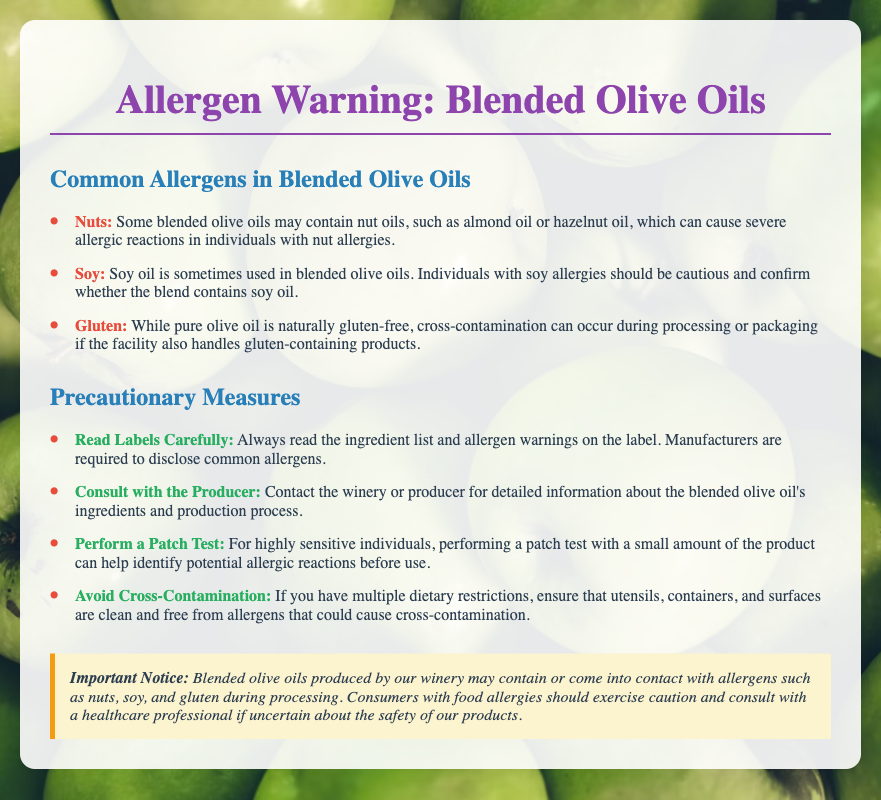What are common allergens in blended olive oils? The common allergens listed in the document include nuts, soy, and gluten.
Answer: Nuts, soy, gluten What should you do if you have a soy allergy? The document advises that individuals with soy allergies should confirm whether the blend contains soy oil.
Answer: Confirm blend What is one precautionary measure for allergy-sensitive individuals? One of the measures suggested is to perform a patch test with a small amount of the product.
Answer: Perform a patch test What important notice is included regarding allergens? The important notice indicates that blended olive oils may contain or come into contact with allergens such as nuts, soy, and gluten during processing.
Answer: May contain allergens How often should you read labels when purchasing olive oil? The document emphasizes that you should always read the ingredient list and allergen warnings on the label.
Answer: Always What color is used for allergen text in the document? The color used for allergen text is red, indicating the seriousness of the information.
Answer: Red 